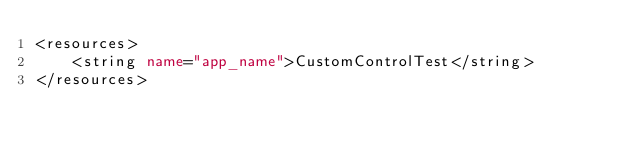Convert code to text. <code><loc_0><loc_0><loc_500><loc_500><_XML_><resources>
    <string name="app_name">CustomControlTest</string>
</resources>
</code> 